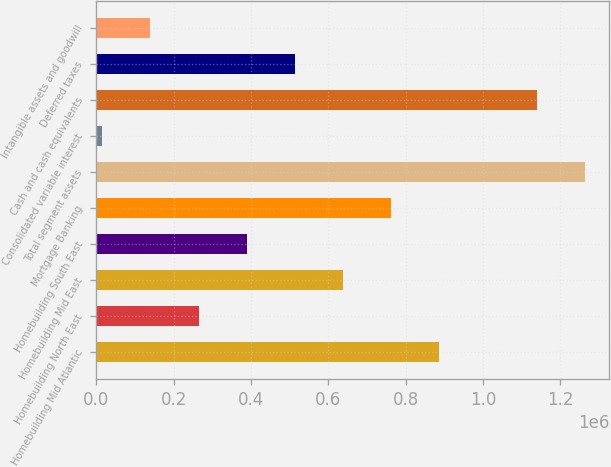Convert chart to OTSL. <chart><loc_0><loc_0><loc_500><loc_500><bar_chart><fcel>Homebuilding Mid Atlantic<fcel>Homebuilding North East<fcel>Homebuilding Mid East<fcel>Homebuilding South East<fcel>Mortgage Banking<fcel>Total segment assets<fcel>Consolidated variable interest<fcel>Cash and cash equivalents<fcel>Deferred taxes<fcel>Intangible assets and goodwill<nl><fcel>885643<fcel>264202<fcel>637067<fcel>388491<fcel>761355<fcel>1.26339e+06<fcel>15626<fcel>1.1391e+06<fcel>512779<fcel>139914<nl></chart> 